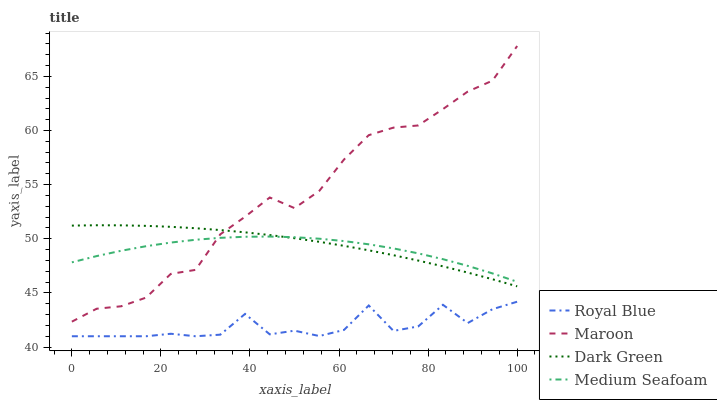Does Royal Blue have the minimum area under the curve?
Answer yes or no. Yes. Does Maroon have the maximum area under the curve?
Answer yes or no. Yes. Does Medium Seafoam have the minimum area under the curve?
Answer yes or no. No. Does Medium Seafoam have the maximum area under the curve?
Answer yes or no. No. Is Dark Green the smoothest?
Answer yes or no. Yes. Is Royal Blue the roughest?
Answer yes or no. Yes. Is Medium Seafoam the smoothest?
Answer yes or no. No. Is Medium Seafoam the roughest?
Answer yes or no. No. Does Royal Blue have the lowest value?
Answer yes or no. Yes. Does Maroon have the lowest value?
Answer yes or no. No. Does Maroon have the highest value?
Answer yes or no. Yes. Does Medium Seafoam have the highest value?
Answer yes or no. No. Is Royal Blue less than Maroon?
Answer yes or no. Yes. Is Maroon greater than Royal Blue?
Answer yes or no. Yes. Does Medium Seafoam intersect Maroon?
Answer yes or no. Yes. Is Medium Seafoam less than Maroon?
Answer yes or no. No. Is Medium Seafoam greater than Maroon?
Answer yes or no. No. Does Royal Blue intersect Maroon?
Answer yes or no. No. 